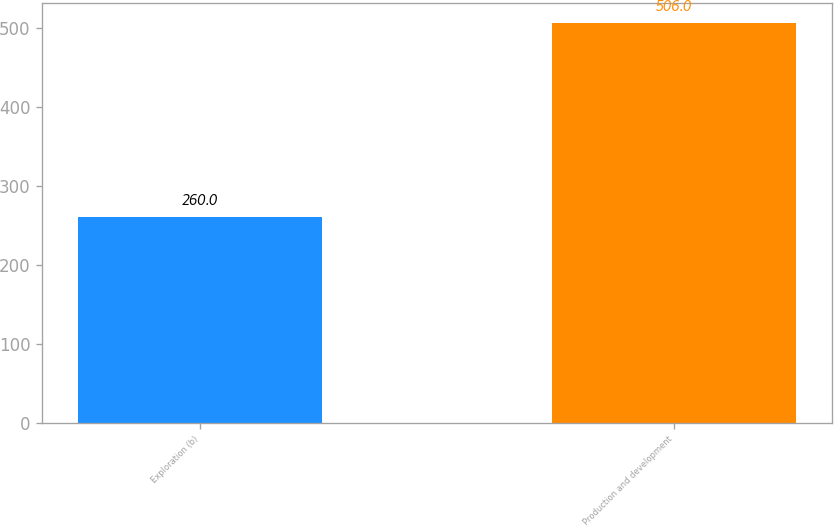Convert chart to OTSL. <chart><loc_0><loc_0><loc_500><loc_500><bar_chart><fcel>Exploration (b)<fcel>Production and development<nl><fcel>260<fcel>506<nl></chart> 